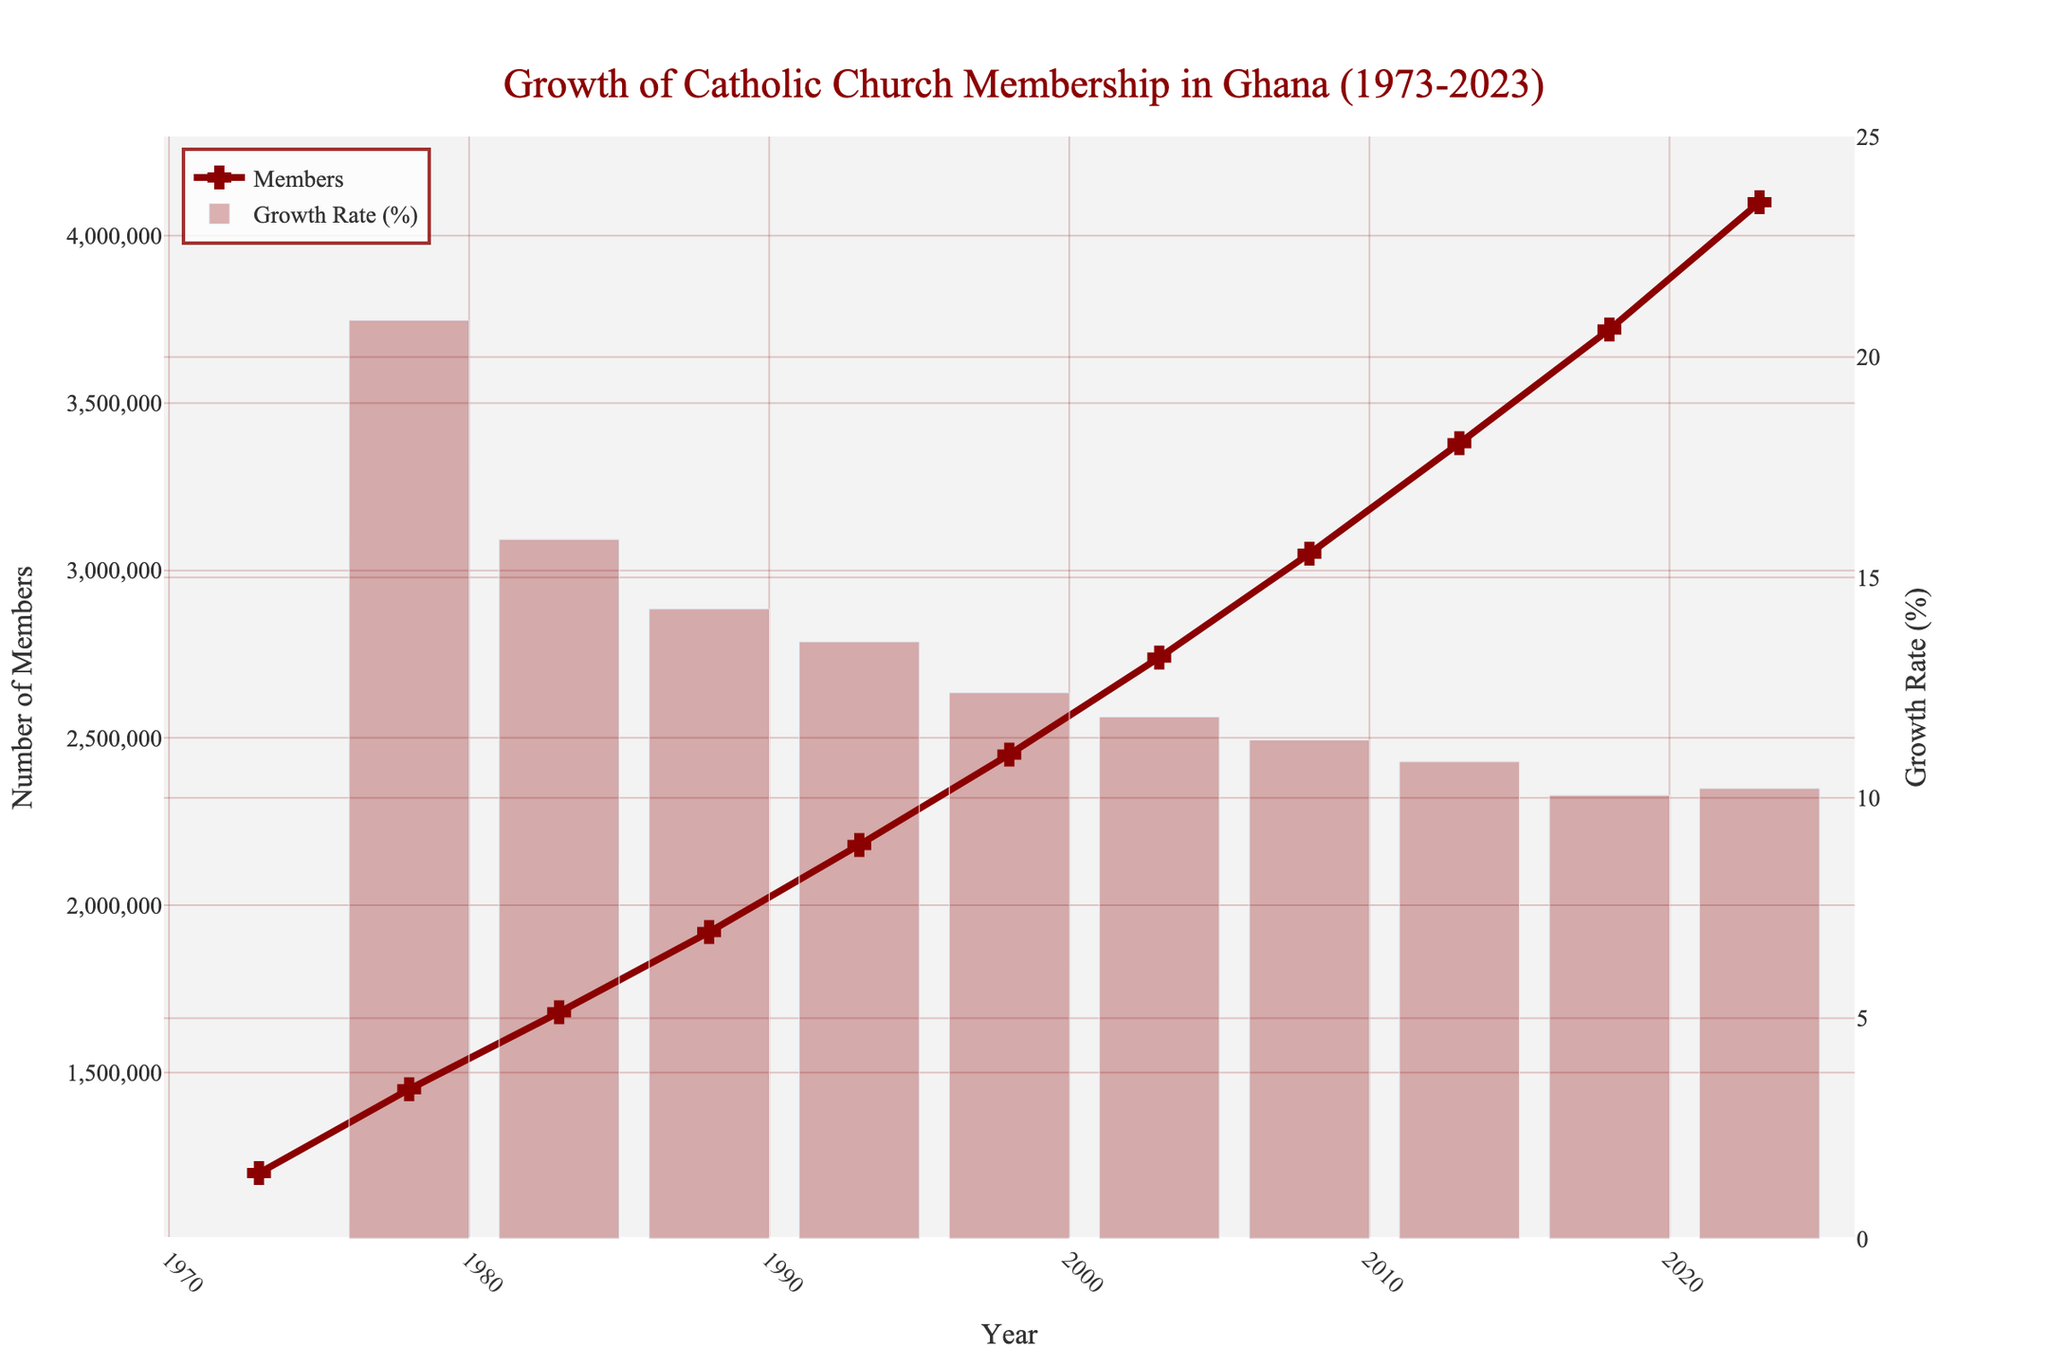What is the total number of Catholic Church members in Ghana in 2023? Look at the y-axis representing 'Number of Members' and find the value for the year 2023 on the x-axis. The number of members for 2023 is listed on the figure.
Answer: 4,100,000 What was the growth rate of Catholic Church membership between 2013 and 2018? Find the bar representing the growth rate between 2013 and 2018 on the secondary y-axis. The height of the bar corresponds to the growth rate in percentage.
Answer: Approximately 10.1% Which year had the highest number of new members compared to the previous year? Look at the bars representing the growth rate and compare their heights. The highest bar represents the highest number of new members relative to the previous year.
Answer: 1973-1978 Between which years did the Catholic Church in Ghana see a decrease in the growth rate compared to the previous period? Compare the heights of the bars sequentially to identify any periods where the bar is shorter than its preceding bar, which indicates a decrease in growth rate.
Answer: 1998-2003 What is the average number of Catholic Church members in Ghana between 1973 and 1988? Add the number of members for the years 1973, 1978, 1983, and 1988, then divide by the number of data points (4). (1,200,000 + 1,450,000 + 1,680,000 + 1,920,000) / 4 = 6,250,000 / 4
Answer: 1,562,500 How did the growth rate change from the period 2003-2008 to 2008-2013? Compare the heights of the bars for the periods 2003-2008 and 2008-2013. Determine if the bar for 2008-2013 is taller, shorter, or equal in height compared to 2003-2008.
Answer: The growth rate decreased What can you infer about the trend in Catholic Church membership from 1973 to 2023? Observe the line connecting the data points for each year. If the line consistently rises, it indicates an overall increase in membership.
Answer: The membership consistently increased What is the approximate increase in the number of members from 1973 to 1983? Subtract the number of members in 1973 from the number in 1983 (1,680,000 - 1,200,000).
Answer: 480,000 Which period had the lowest growth rate in Catholic Church membership in Ghana? Identify the bar with the shortest height on the secondary y-axis. This lowest bar indicates the period with the lowest growth rate.
Answer: 2018-2023 